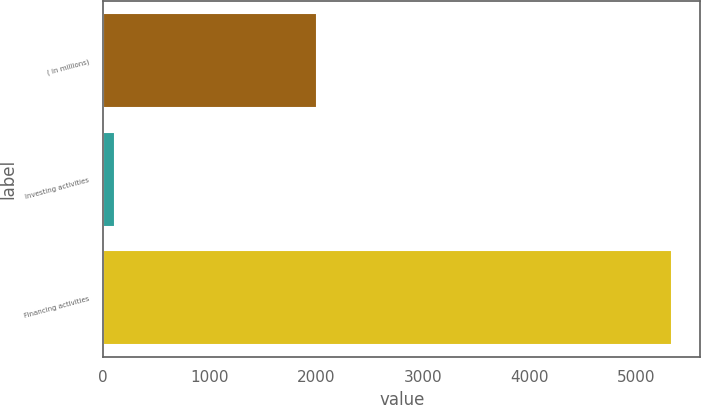<chart> <loc_0><loc_0><loc_500><loc_500><bar_chart><fcel>( in millions)<fcel>Investing activities<fcel>Financing activities<nl><fcel>2007<fcel>115<fcel>5339<nl></chart> 